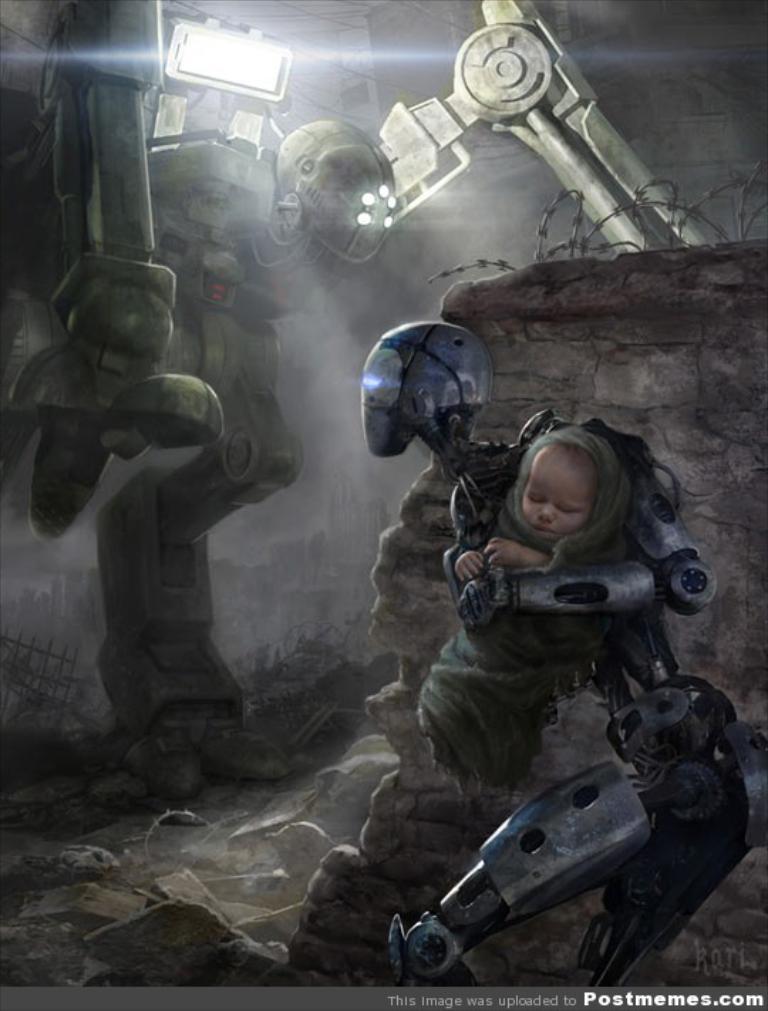Describe this image in one or two sentences. In this image I can see the depiction picture. In this picture I can see few robots and a child. On the top left side of the image I can see a light and on the bottom right side I can see a watermark. On the right side of the image I can see the wall and on it I can see few iron wire like things. I can also see few stuffs on the ground. 